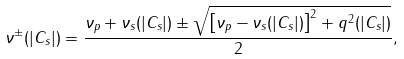<formula> <loc_0><loc_0><loc_500><loc_500>\nu ^ { \pm } ( | C _ { s } | ) = \frac { \nu _ { p } + \nu _ { s } ( | C _ { s } | ) \pm \sqrt { \left [ \nu _ { p } - \nu _ { s } ( | C _ { s } | ) \right ] ^ { 2 } + q ^ { 2 } ( | C _ { s } | ) } } { 2 } ,</formula> 